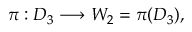<formula> <loc_0><loc_0><loc_500><loc_500>\pi \colon D _ { 3 } \longrightarrow W _ { 2 } = \pi ( D _ { 3 } ) ,</formula> 